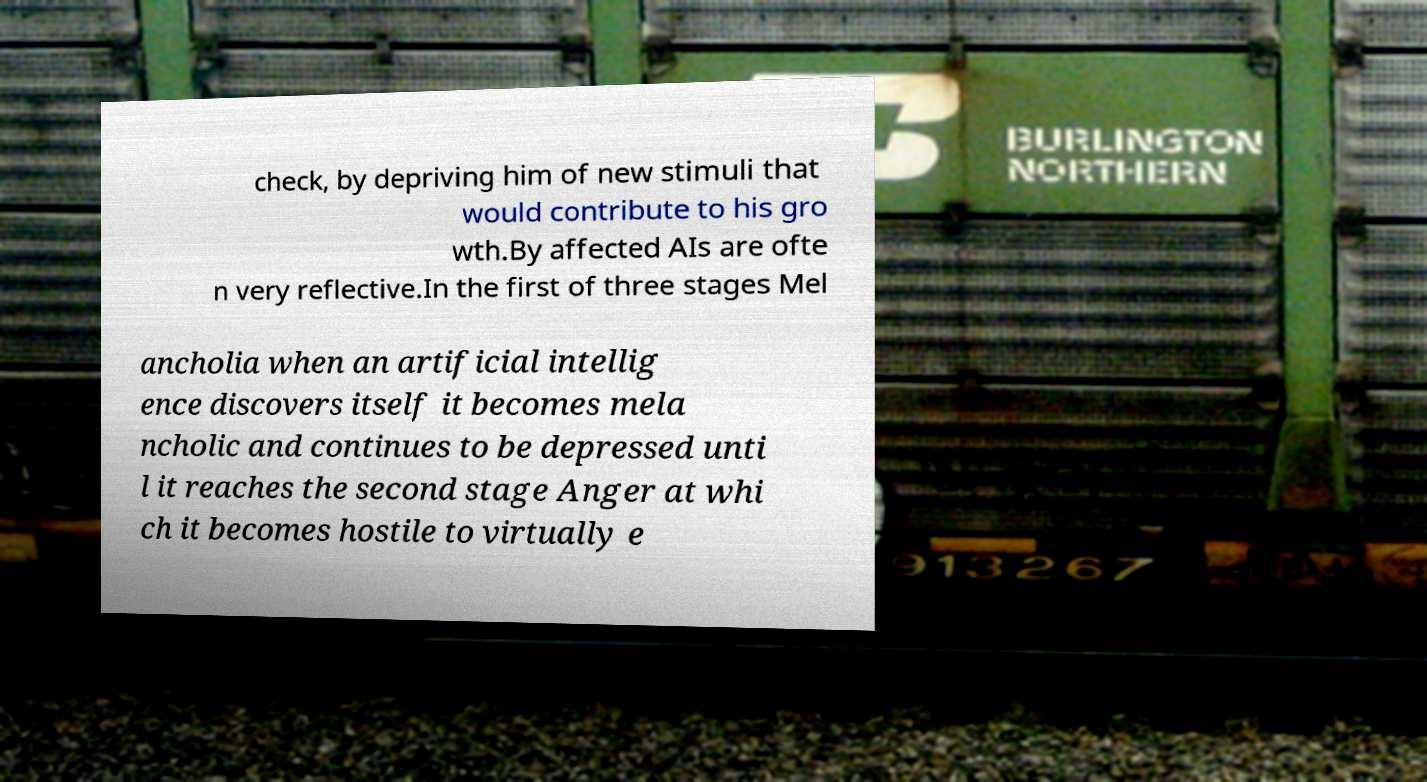What messages or text are displayed in this image? I need them in a readable, typed format. check, by depriving him of new stimuli that would contribute to his gro wth.By affected AIs are ofte n very reflective.In the first of three stages Mel ancholia when an artificial intellig ence discovers itself it becomes mela ncholic and continues to be depressed unti l it reaches the second stage Anger at whi ch it becomes hostile to virtually e 